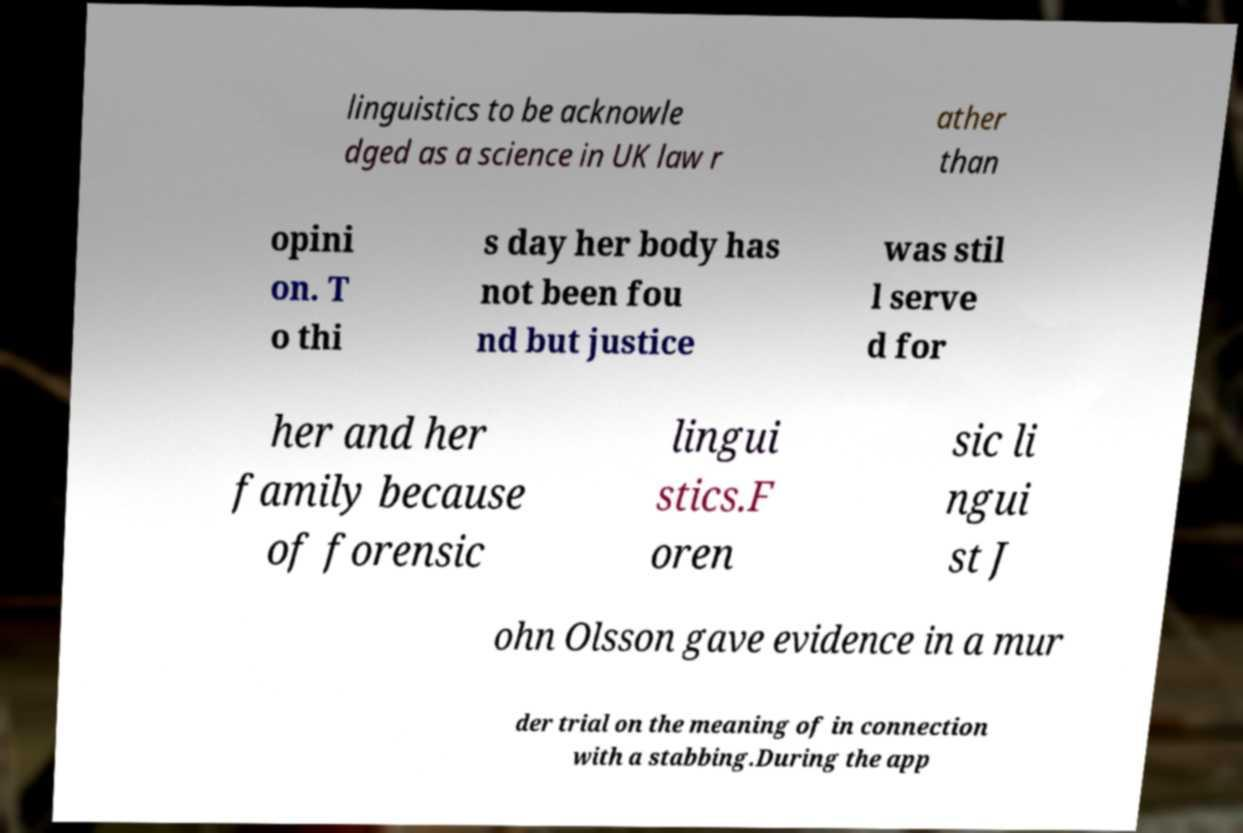Can you accurately transcribe the text from the provided image for me? linguistics to be acknowle dged as a science in UK law r ather than opini on. T o thi s day her body has not been fou nd but justice was stil l serve d for her and her family because of forensic lingui stics.F oren sic li ngui st J ohn Olsson gave evidence in a mur der trial on the meaning of in connection with a stabbing.During the app 